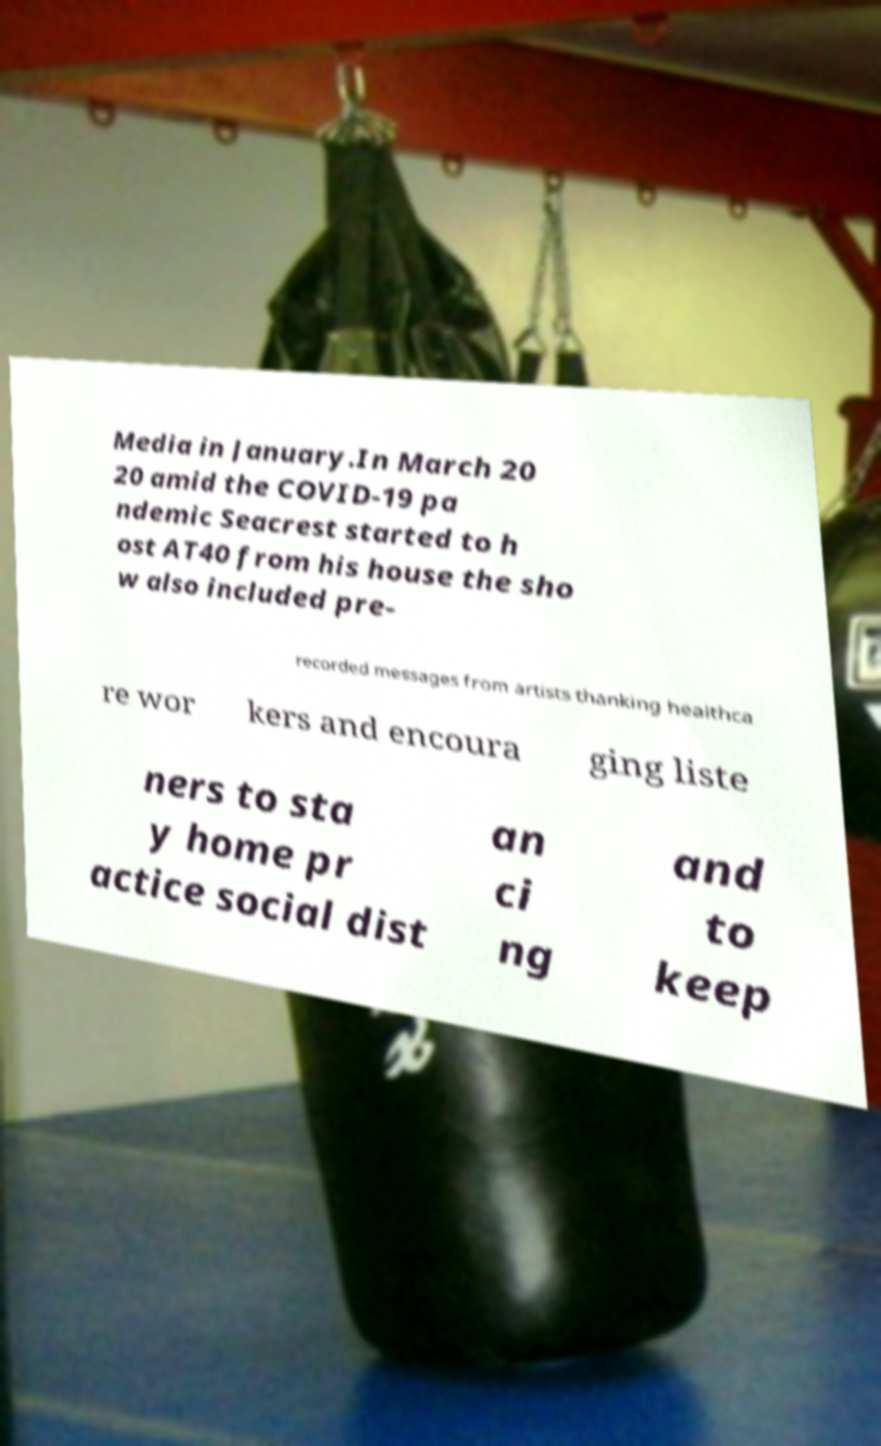What messages or text are displayed in this image? I need them in a readable, typed format. Media in January.In March 20 20 amid the COVID-19 pa ndemic Seacrest started to h ost AT40 from his house the sho w also included pre- recorded messages from artists thanking healthca re wor kers and encoura ging liste ners to sta y home pr actice social dist an ci ng and to keep 